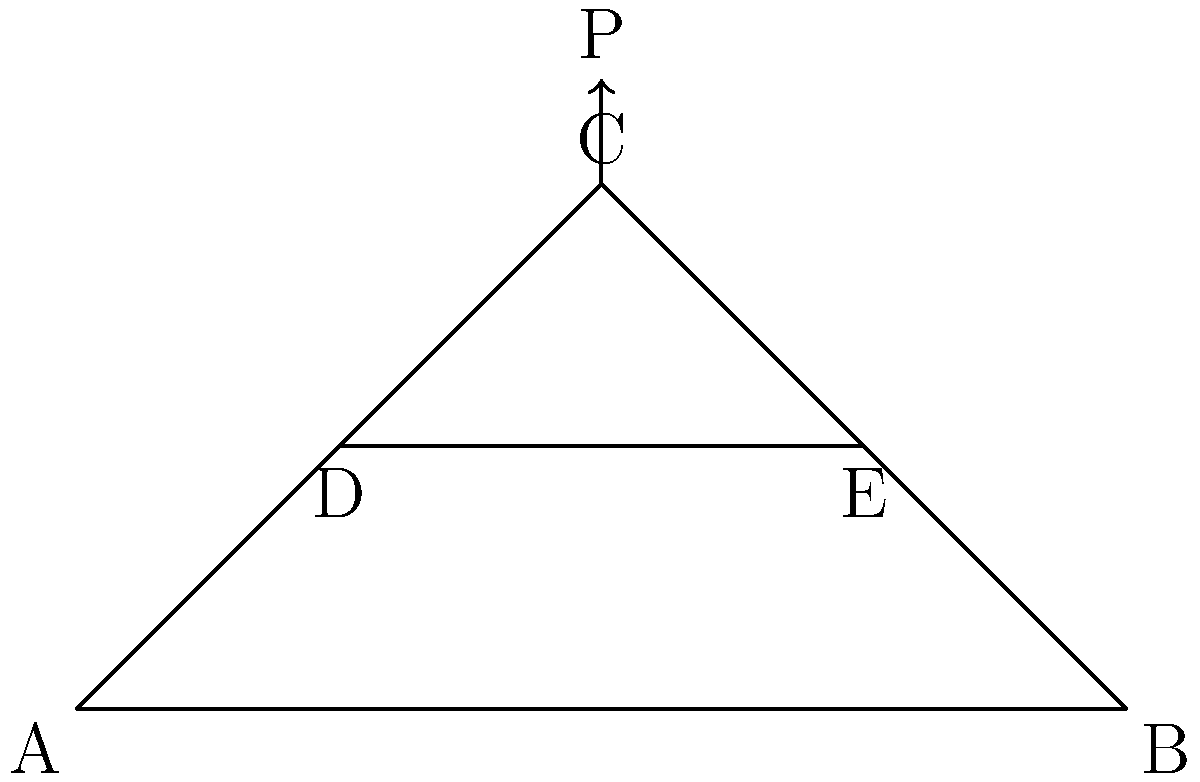Remember when we worked on that bridge project together, Rahim? Let's revisit that concept. For the truss shown in the figure, which member experiences the highest compressive force when a vertical load P is applied at point C? Assume all joints are pin connections and the truss is symmetrical. To determine the member with the highest compressive force, let's analyze the truss step-by-step:

1. Recognize that due to symmetry, reactions at A and B will be equal to P/2.

2. Using the method of joints, start at joint C:
   - Vertical equilibrium: $C_V + P = 0$, so $C_V = -P$ (compression)
   - Horizontal equilibrium: $C_H = 0$

3. Members AC and BC:
   - Force in AC = Force in BC = $\frac{P}{\sin \theta}$, where $\theta$ is the angle between AC and the horizontal
   - These forces are compressive

4. Analyze joint D (or E due to symmetry):
   - Force in DE is tensile and horizontal
   - Force in AD is compressive and equal to the horizontal component of force in AC

5. Compare magnitudes:
   - Force in AC and BC: $\frac{P}{\sin \theta}$
   - Force in AD and BD: $\frac{P}{\tan \theta}$

6. Since $\sin \theta < \tan \theta$ for $0° < \theta < 90°$, the force in AC and BC will be larger in magnitude than the force in AD and BD.

Therefore, members AC and BC experience the highest compressive force.
Answer: AC and BC 